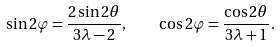<formula> <loc_0><loc_0><loc_500><loc_500>\sin 2 \varphi = \frac { 2 \sin 2 \theta } { 3 \lambda - 2 } , \quad \cos 2 \varphi = \frac { \cos 2 \theta } { 3 \lambda + 1 } .</formula> 